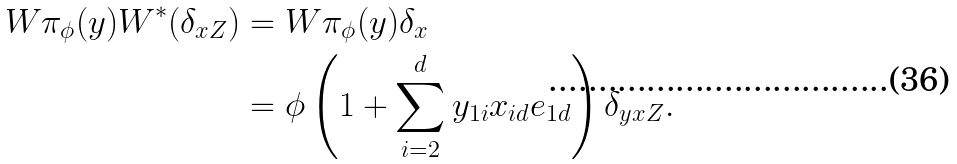Convert formula to latex. <formula><loc_0><loc_0><loc_500><loc_500>W \pi _ { \phi } ( y ) W ^ { * } ( \delta _ { x Z } ) & = W \pi _ { \phi } ( y ) \delta _ { x } \\ & = \phi \left ( 1 + \sum _ { i = 2 } ^ { d } y _ { 1 i } x _ { i d } e _ { 1 d } \right ) \delta _ { y x Z } .</formula> 